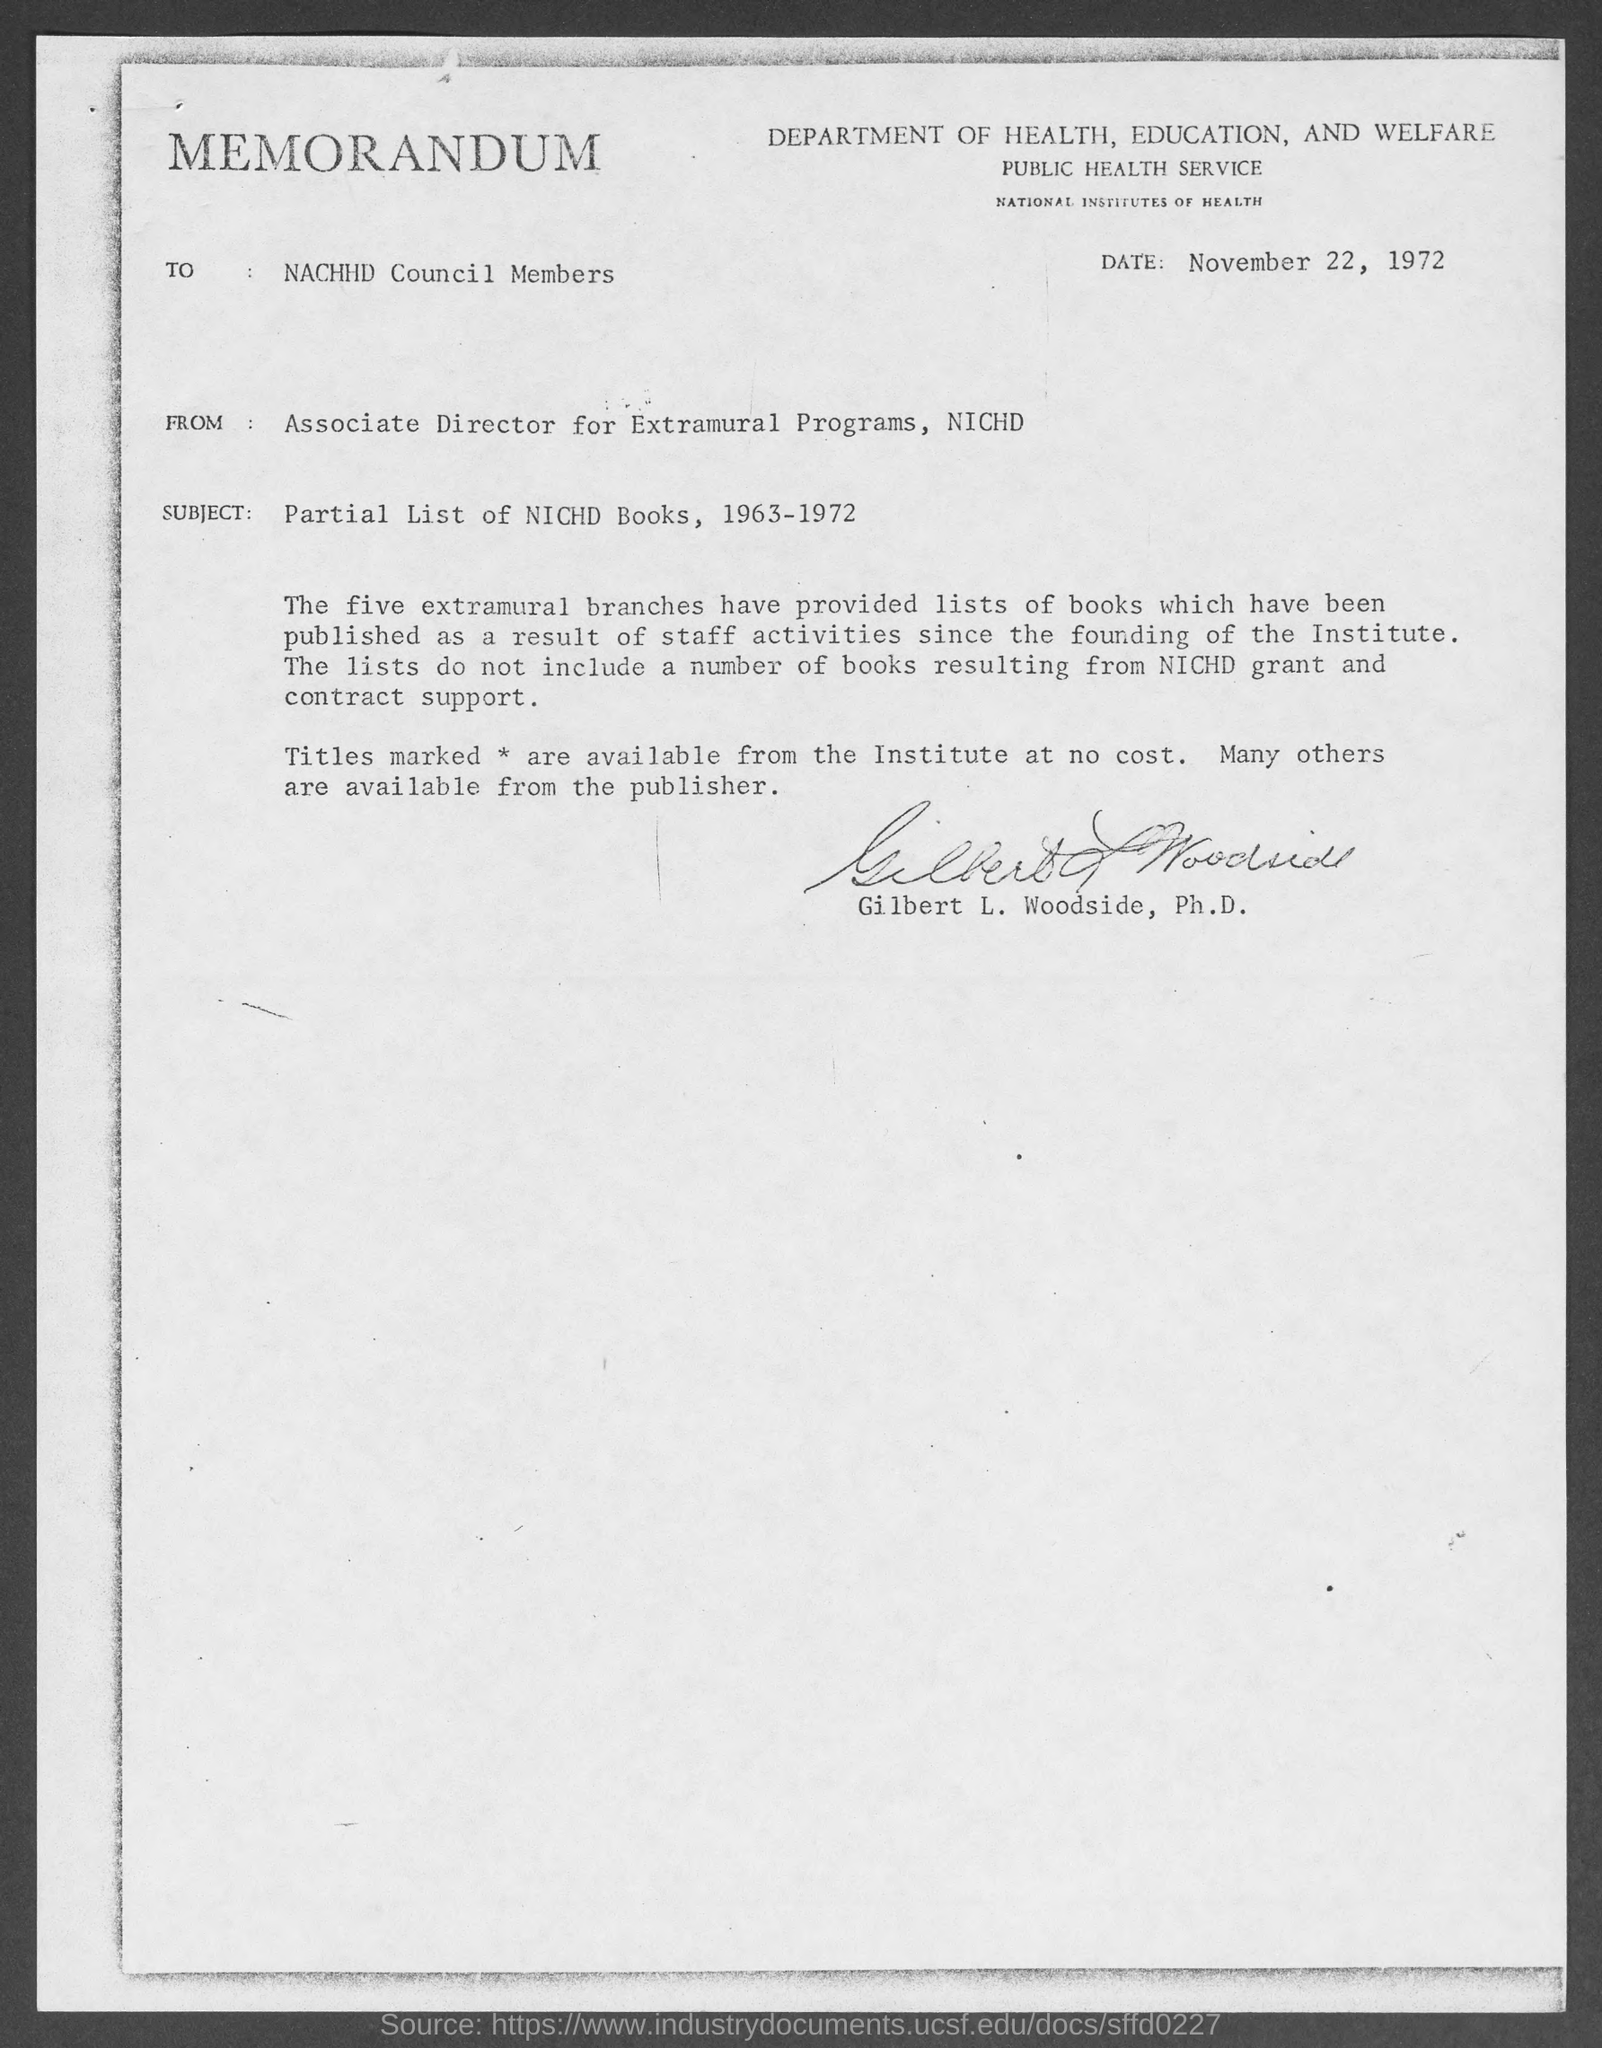Mention a couple of crucial points in this snapshot. The memorandum is dated November 22, 1972. Gilbert L. Woodside, Ph.D, holds the position of Associate Director. The subject of the memorandum is "Partial List of NICHD Books, 1963-1972. 